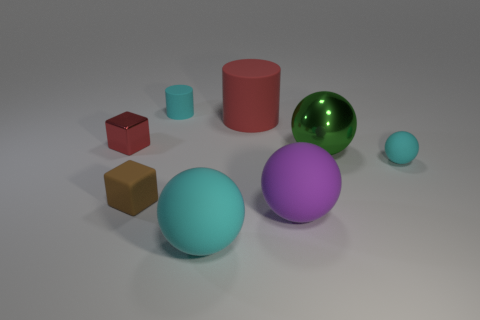Is the size of the purple sphere the same as the green metal thing?
Ensure brevity in your answer.  Yes. There is a big matte sphere that is to the right of the big red matte cylinder; is its color the same as the big matte cylinder?
Your response must be concise. No. What is the shape of the object that is both left of the large red matte thing and behind the red metallic thing?
Your answer should be compact. Cylinder. There is a small cyan object that is the same shape as the large purple thing; what is it made of?
Your answer should be very brief. Rubber. What shape is the metal thing in front of the red object that is to the left of the cyan object behind the red metal block?
Provide a short and direct response. Sphere. What is the material of the big sphere that is the same color as the small cylinder?
Offer a very short reply. Rubber. How many tiny things are the same shape as the big green metallic object?
Provide a short and direct response. 1. There is a large rubber object that is behind the red cube; is it the same color as the block that is behind the large shiny ball?
Offer a terse response. Yes. There is a green ball that is the same size as the red rubber cylinder; what is its material?
Provide a short and direct response. Metal. Is there a red metallic sphere that has the same size as the red metal object?
Your response must be concise. No. 